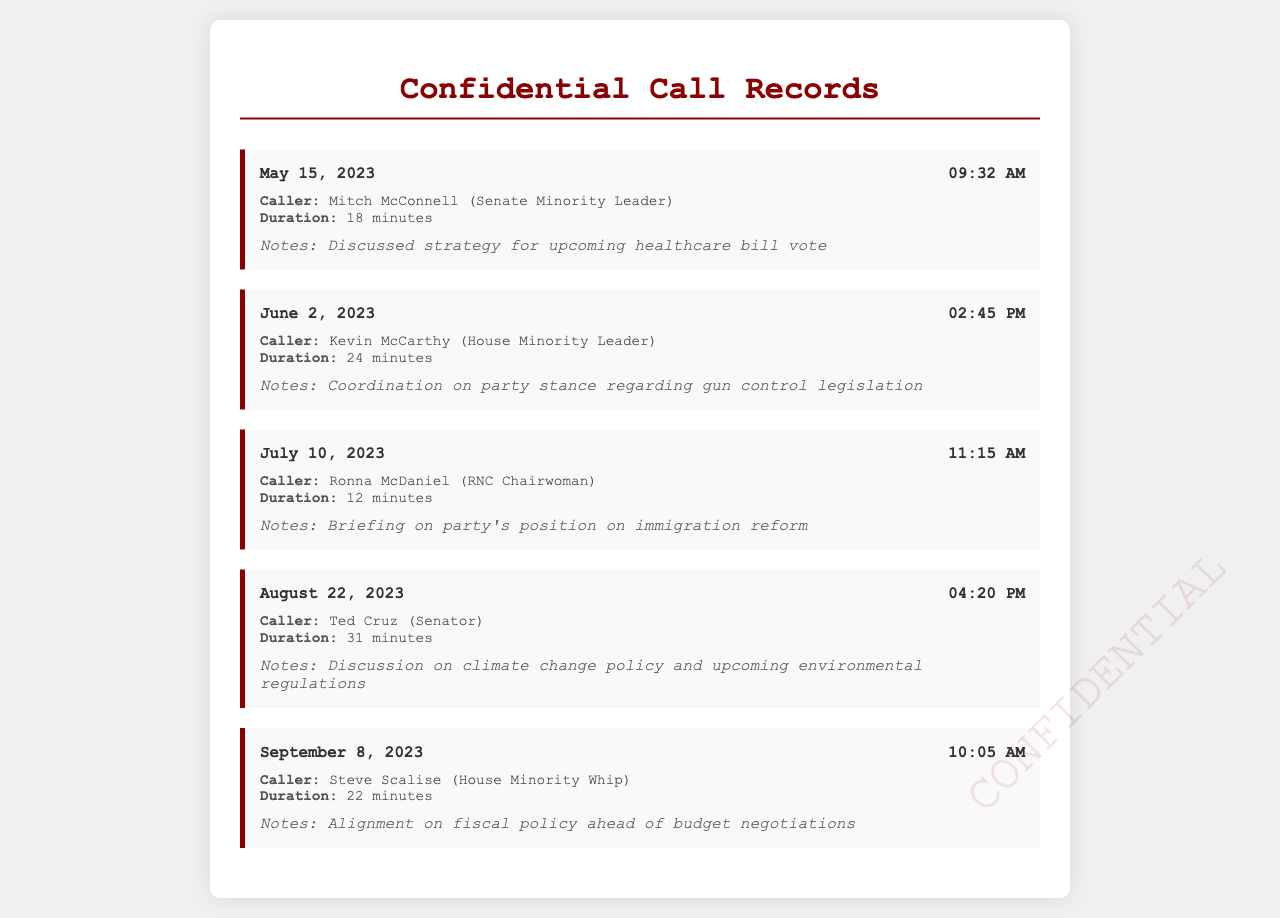What is the date of the call with Mitch McConnell? The document lists the date of the call with Mitch McConnell as May 15, 2023.
Answer: May 15, 2023 How long was the call with Kevin McCarthy? The duration of the call with Kevin McCarthy is stated as 24 minutes.
Answer: 24 minutes Who was the caller on July 10, 2023? The document specifies that the caller on July 10, 2023, was Ronna McDaniel.
Answer: Ronna McDaniel What was the main topic discussed in the call with Ted Cruz? The notes indicate that the discussion with Ted Cruz focused on climate change policy and upcoming environmental regulations.
Answer: Climate change policy Who is the House Minority Whip according to the document? The document identifies Steve Scalise as the House Minority Whip.
Answer: Steve Scalise What time did the conversation with Ronna McDaniel occur? The time of the conversation with Ronna McDaniel is noted as 11:15 AM.
Answer: 11:15 AM How many calls are documented in total? The total number of calls listed in the document is five.
Answer: Five What was the duration of the call with Ronna McDaniel? The document states that the duration of the call with Ronna McDaniel was 12 minutes.
Answer: 12 minutes 